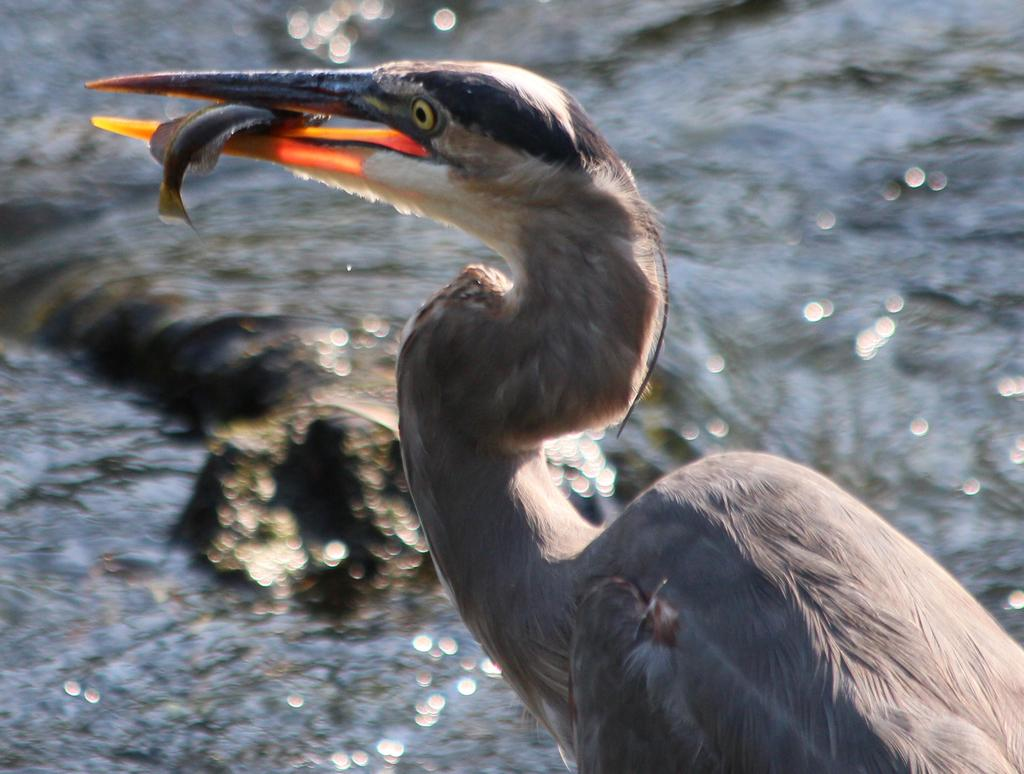What type of animal can be seen in the image? There is a bird in the image. What is the bird holding in its mouth? The bird has a fish in its mouth. What can be seen in the background of the image? There is water visible in the background of the image. What type of destruction is the bird causing in the image? There is no destruction present in the image; the bird is simply holding a fish in its mouth. 